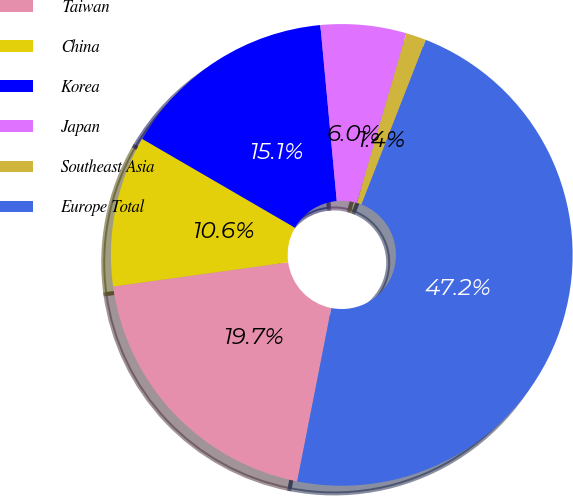Convert chart. <chart><loc_0><loc_0><loc_500><loc_500><pie_chart><fcel>Taiwan<fcel>China<fcel>Korea<fcel>Japan<fcel>Southeast Asia<fcel>Europe Total<nl><fcel>19.72%<fcel>10.57%<fcel>15.14%<fcel>5.99%<fcel>1.42%<fcel>47.17%<nl></chart> 